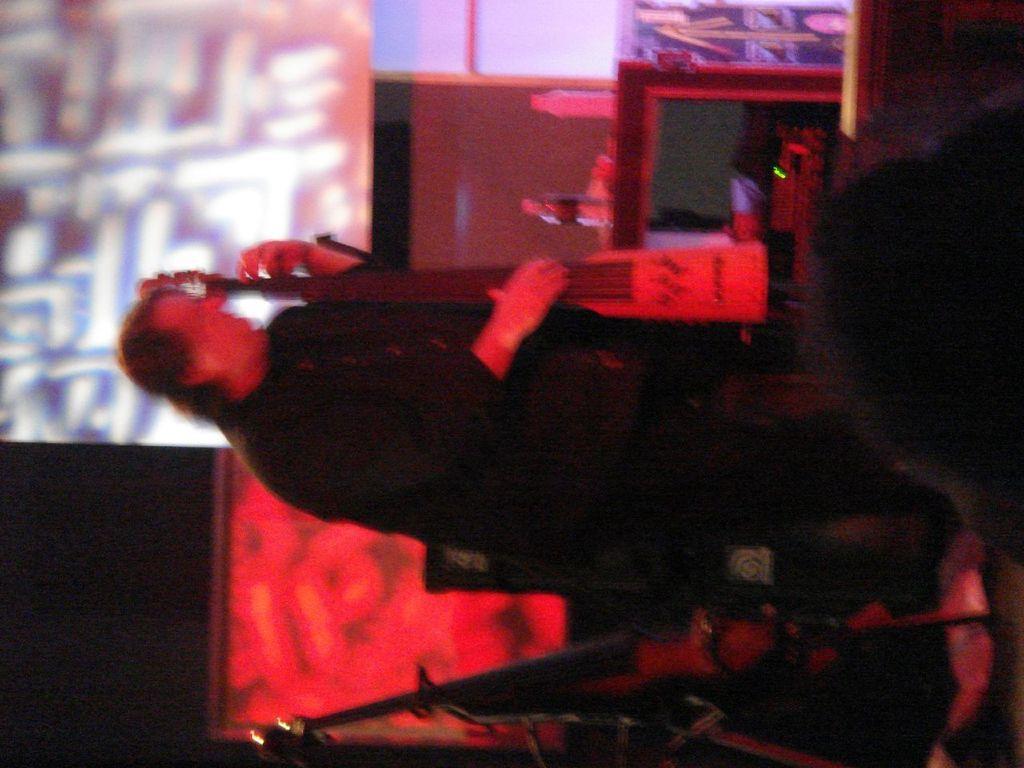How would you summarize this image in a sentence or two? In this image there is a person standing and holding an musical instrument , there are bottles on the table, and other items in the background. 